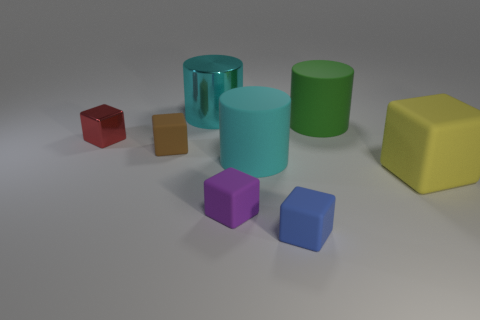Subtract 1 cubes. How many cubes are left? 4 Subtract all blue cubes. How many cubes are left? 4 Subtract all large rubber cubes. How many cubes are left? 4 Subtract all cyan blocks. Subtract all green spheres. How many blocks are left? 5 Add 2 green cylinders. How many objects exist? 10 Subtract all cylinders. How many objects are left? 5 Add 8 red metal cubes. How many red metal cubes exist? 9 Subtract 0 purple balls. How many objects are left? 8 Subtract all small metal cubes. Subtract all tiny objects. How many objects are left? 3 Add 8 large yellow matte things. How many large yellow matte things are left? 9 